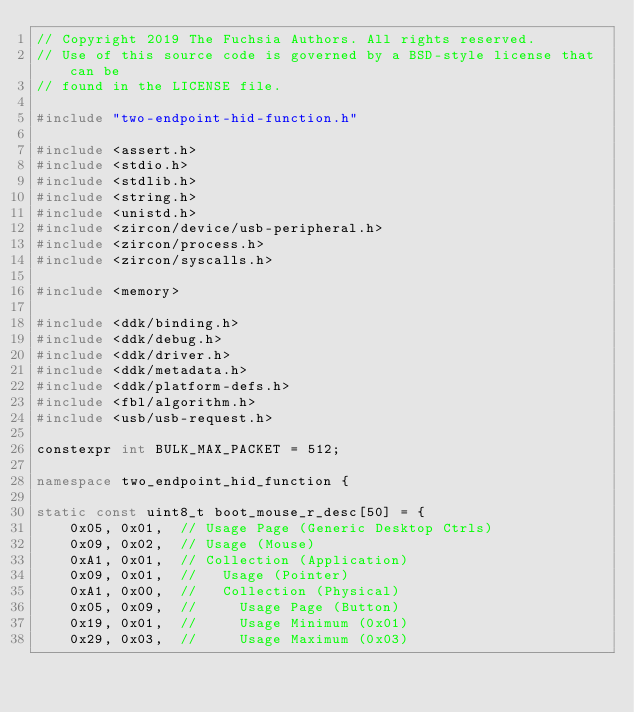Convert code to text. <code><loc_0><loc_0><loc_500><loc_500><_C++_>// Copyright 2019 The Fuchsia Authors. All rights reserved.
// Use of this source code is governed by a BSD-style license that can be
// found in the LICENSE file.

#include "two-endpoint-hid-function.h"

#include <assert.h>
#include <stdio.h>
#include <stdlib.h>
#include <string.h>
#include <unistd.h>
#include <zircon/device/usb-peripheral.h>
#include <zircon/process.h>
#include <zircon/syscalls.h>

#include <memory>

#include <ddk/binding.h>
#include <ddk/debug.h>
#include <ddk/driver.h>
#include <ddk/metadata.h>
#include <ddk/platform-defs.h>
#include <fbl/algorithm.h>
#include <usb/usb-request.h>

constexpr int BULK_MAX_PACKET = 512;

namespace two_endpoint_hid_function {

static const uint8_t boot_mouse_r_desc[50] = {
    0x05, 0x01,  // Usage Page (Generic Desktop Ctrls)
    0x09, 0x02,  // Usage (Mouse)
    0xA1, 0x01,  // Collection (Application)
    0x09, 0x01,  //   Usage (Pointer)
    0xA1, 0x00,  //   Collection (Physical)
    0x05, 0x09,  //     Usage Page (Button)
    0x19, 0x01,  //     Usage Minimum (0x01)
    0x29, 0x03,  //     Usage Maximum (0x03)</code> 